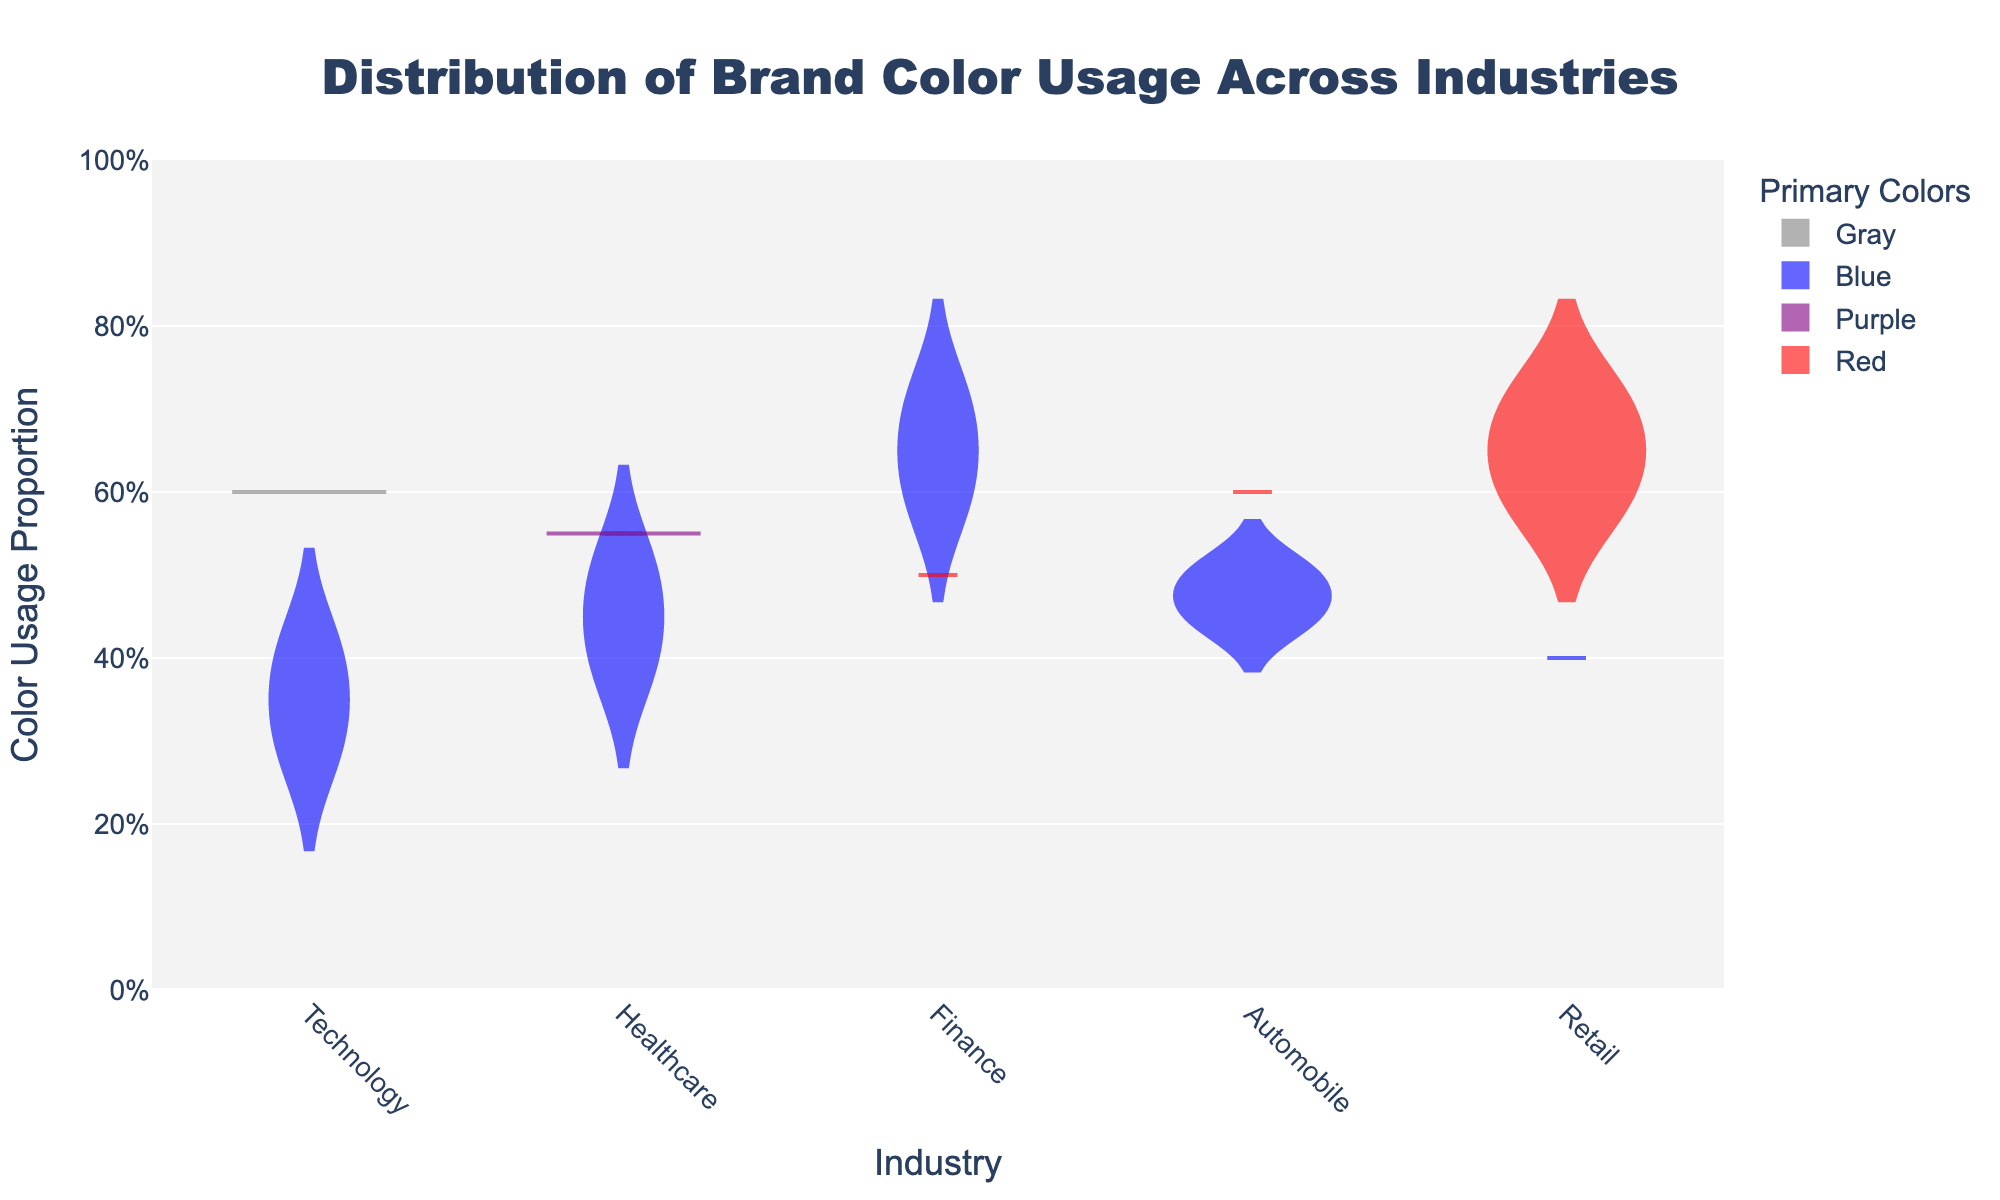What is the title of the figure? The title of the figure is located at the top center of the plot
Answer: Distribution of Brand Color Usage Across Industries What is the primary color used most in the 'Technology' industry? Check the box plot for the 'Technology' industry and identify which color has more occurrences
Answer: Blue Which industry has the highest proportion of Red color usage? Look for the highest point on the Green color violin plots across the different industries
Answer: Retail What is the average proportion of Blue color usage in the 'Healthcare' industry? Identify the Blue color usages in the Healthcare industry and calculate the average: (0.5 + 0.4) / 2
Answer: 0.45 Which color has the widest variability in the 'Finance' industry? Compare the widths of the different violin plots in the Finance industry. Blue has a wider spread
Answer: Blue In the 'Retail' industry, which color has the highest mean line within the violin plot? Look for the violin plot with the highest mean line in the Retail industry. Red is higher than Blue
Answer: Red What industry shows the least variability in Blue color usage? Compare the spreads of the Blue color violin plots across different industries and find the one with the smallest width
Answer: Retail Is there any industry where Purple is a primary color? Look for a violin plot for the Purple color. It only appears in the Healthcare industry
Answer: Yes, Healthcare Compare the maximum proportion of Red color usage in the 'Automobile' and 'Retail' industries. Which one is higher? Find the highest points in the Red violin plots for both categories. Retail is higher since its maximum is 0.7 compared to 0.6 in Automobile
Answer: Retail 